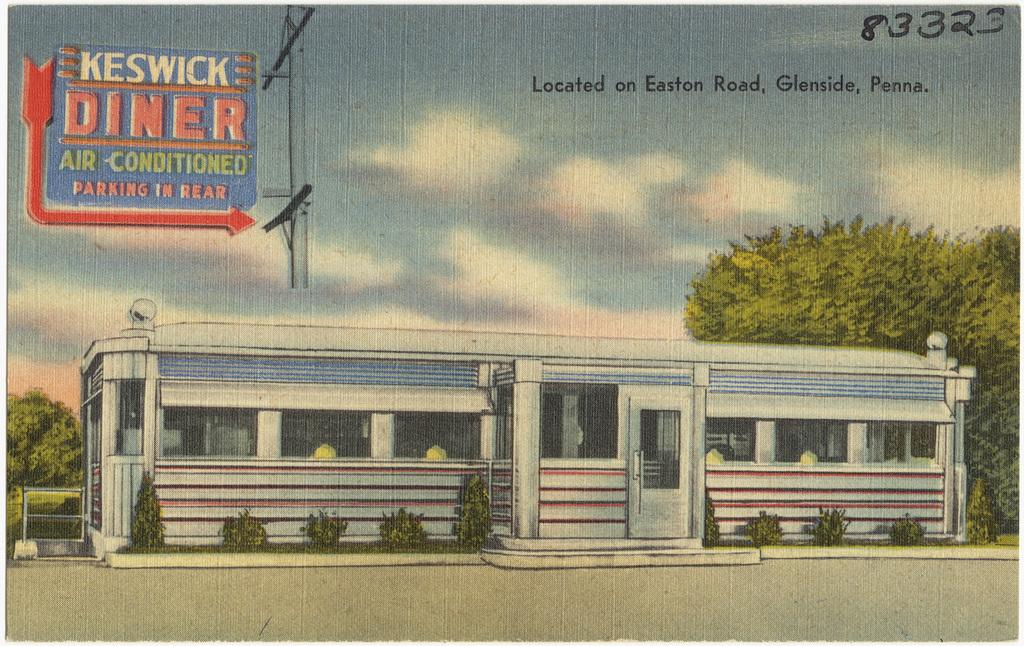What type of structure is in the image? There is a building in the image. What is the color of the building? The building is white. What can be seen in the background of the image? There are trees and the sky visible in the background of the image. What is the color of the trees? The trees are green. How would you describe the color of the sky? The sky has both white and blue colors. Can you describe the blue object in the image? There is a blue color board attached to a pole in the image. What advice does the grandmother give to the organization in the alley in the image? There is no grandmother, organization, or alley present in the image. 